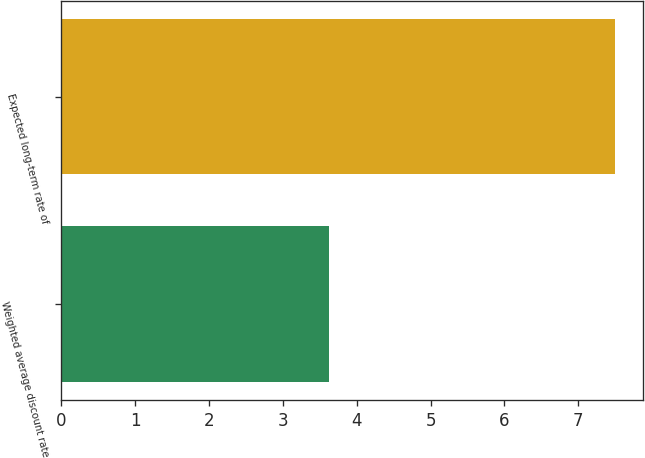<chart> <loc_0><loc_0><loc_500><loc_500><bar_chart><fcel>Weighted average discount rate<fcel>Expected long-term rate of<nl><fcel>3.62<fcel>7.5<nl></chart> 